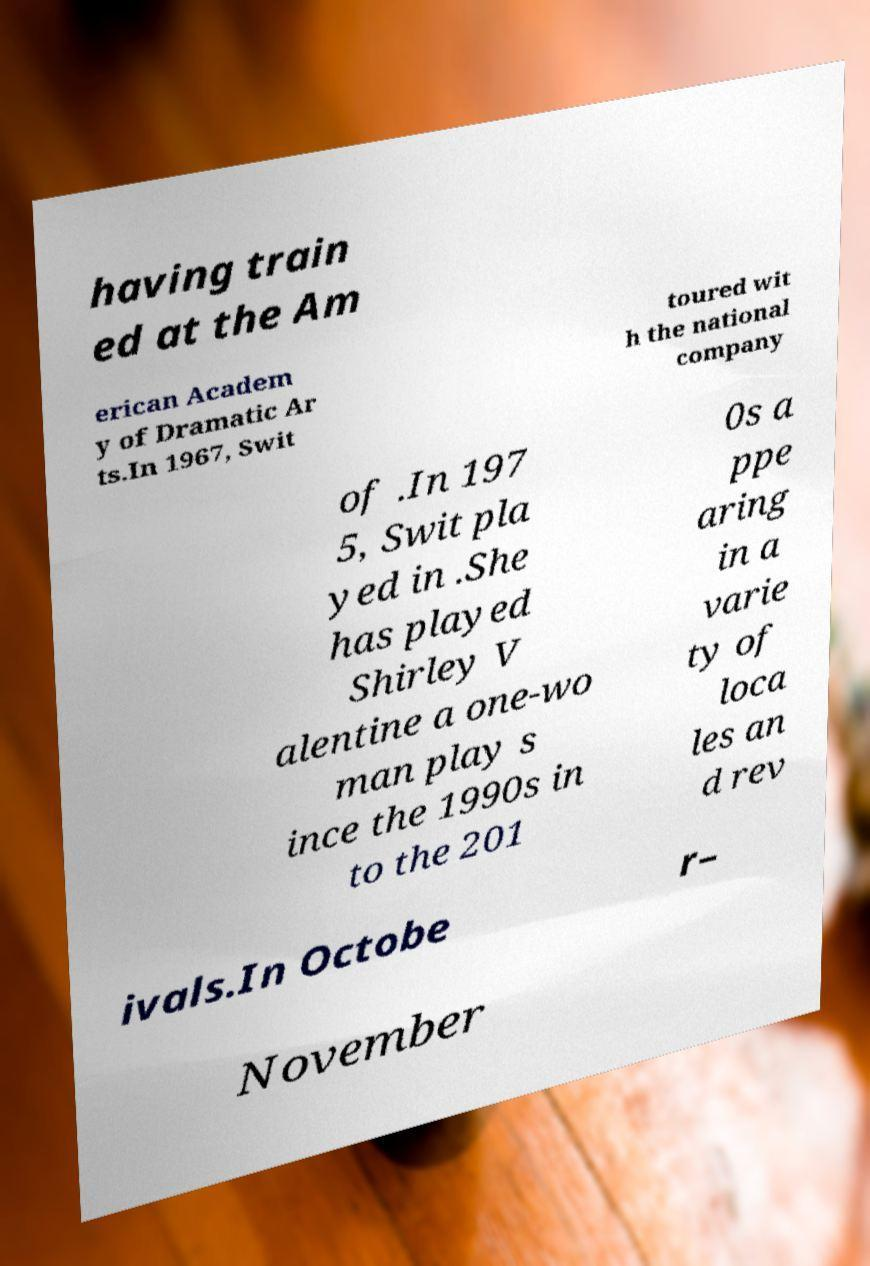Could you assist in decoding the text presented in this image and type it out clearly? having train ed at the Am erican Academ y of Dramatic Ar ts.In 1967, Swit toured wit h the national company of .In 197 5, Swit pla yed in .She has played Shirley V alentine a one-wo man play s ince the 1990s in to the 201 0s a ppe aring in a varie ty of loca les an d rev ivals.In Octobe r– November 